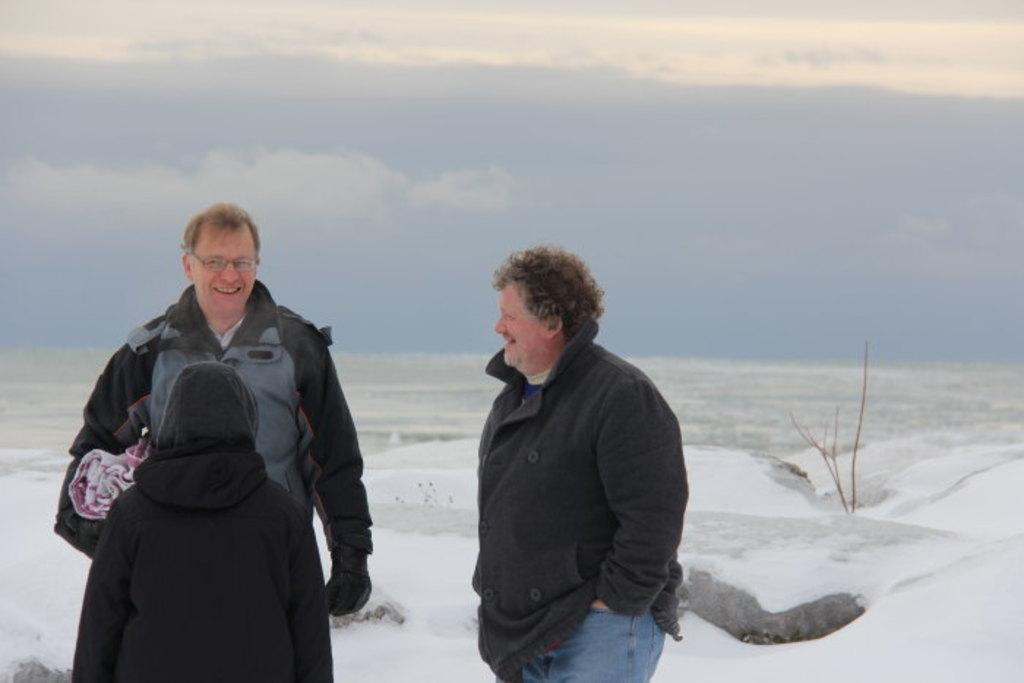How many people are in the image? There is a group of persons in the image, but the exact number is not specified. What are the people in the image doing? The persons are standing and smiling in the image. Can you describe the clothing of one of the persons? At least one person is wearing a jacket. What can be seen in the background of the image? Ice and the sky are visible in the image. What type of protest is taking place in the image? There is no protest present in the image; the persons are simply standing and smiling. What does the truck in the image look like? There is no truck present in the image. 